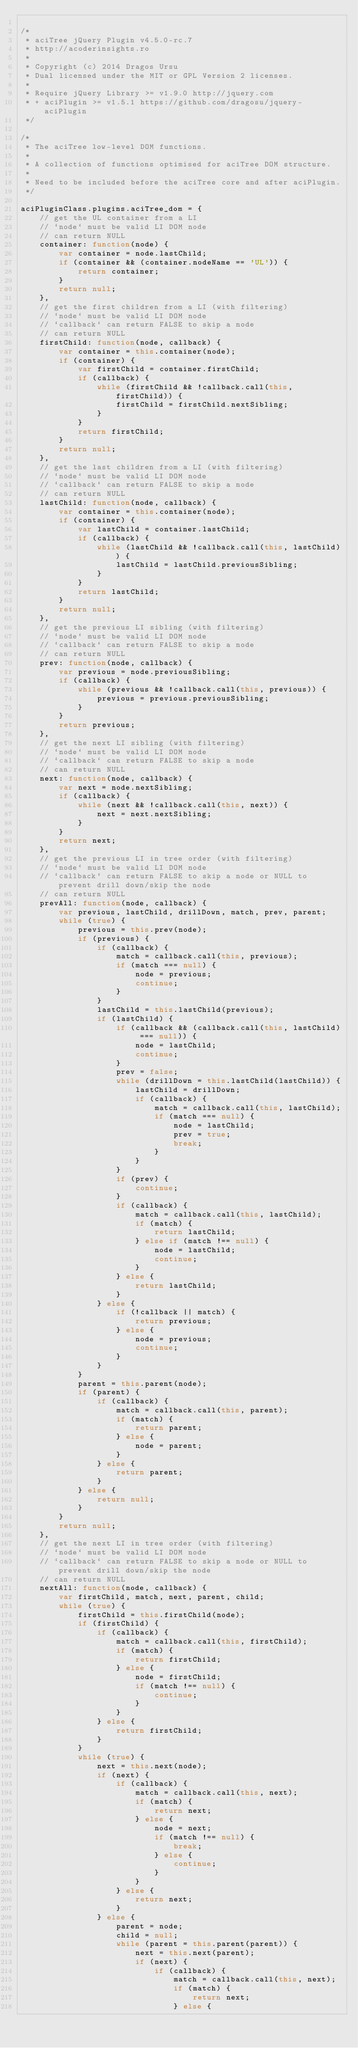<code> <loc_0><loc_0><loc_500><loc_500><_JavaScript_>
/*
 * aciTree jQuery Plugin v4.5.0-rc.7
 * http://acoderinsights.ro
 *
 * Copyright (c) 2014 Dragos Ursu
 * Dual licensed under the MIT or GPL Version 2 licenses.
 *
 * Require jQuery Library >= v1.9.0 http://jquery.com
 * + aciPlugin >= v1.5.1 https://github.com/dragosu/jquery-aciPlugin
 */

/*
 * The aciTree low-level DOM functions.
 *
 * A collection of functions optimised for aciTree DOM structure.
 *
 * Need to be included before the aciTree core and after aciPlugin.
 */

aciPluginClass.plugins.aciTree_dom = {
    // get the UL container from a LI
    // `node` must be valid LI DOM node
    // can return NULL
    container: function(node) {
        var container = node.lastChild;
        if (container && (container.nodeName == 'UL')) {
            return container;
        }
        return null;
    },
    // get the first children from a LI (with filtering)
    // `node` must be valid LI DOM node
    // `callback` can return FALSE to skip a node
    // can return NULL
    firstChild: function(node, callback) {
        var container = this.container(node);
        if (container) {
            var firstChild = container.firstChild;
            if (callback) {
                while (firstChild && !callback.call(this, firstChild)) {
                    firstChild = firstChild.nextSibling;
                }
            }
            return firstChild;
        }
        return null;
    },
    // get the last children from a LI (with filtering)
    // `node` must be valid LI DOM node
    // `callback` can return FALSE to skip a node
    // can return NULL
    lastChild: function(node, callback) {
        var container = this.container(node);
        if (container) {
            var lastChild = container.lastChild;
            if (callback) {
                while (lastChild && !callback.call(this, lastChild)) {
                    lastChild = lastChild.previousSibling;
                }
            }
            return lastChild;
        }
        return null;
    },
    // get the previous LI sibling (with filtering)
    // `node` must be valid LI DOM node
    // `callback` can return FALSE to skip a node
    // can return NULL
    prev: function(node, callback) {
        var previous = node.previousSibling;
        if (callback) {
            while (previous && !callback.call(this, previous)) {
                previous = previous.previousSibling;
            }
        }
        return previous;
    },
    // get the next LI sibling (with filtering)
    // `node` must be valid LI DOM node
    // `callback` can return FALSE to skip a node
    // can return NULL
    next: function(node, callback) {
        var next = node.nextSibling;
        if (callback) {
            while (next && !callback.call(this, next)) {
                next = next.nextSibling;
            }
        }
        return next;
    },
    // get the previous LI in tree order (with filtering)
    // `node` must be valid LI DOM node
    // `callback` can return FALSE to skip a node or NULL to prevent drill down/skip the node
    // can return NULL
    prevAll: function(node, callback) {
        var previous, lastChild, drillDown, match, prev, parent;
        while (true) {
            previous = this.prev(node);
            if (previous) {
                if (callback) {
                    match = callback.call(this, previous);
                    if (match === null) {
                        node = previous;
                        continue;
                    }
                }
                lastChild = this.lastChild(previous);
                if (lastChild) {
                    if (callback && (callback.call(this, lastChild) === null)) {
                        node = lastChild;
                        continue;
                    }
                    prev = false;
                    while (drillDown = this.lastChild(lastChild)) {
                        lastChild = drillDown;
                        if (callback) {
                            match = callback.call(this, lastChild);
                            if (match === null) {
                                node = lastChild;
                                prev = true;
                                break;
                            }
                        }
                    }
                    if (prev) {
                        continue;
                    }
                    if (callback) {
                        match = callback.call(this, lastChild);
                        if (match) {
                            return lastChild;
                        } else if (match !== null) {
                            node = lastChild;
                            continue;
                        }
                    } else {
                        return lastChild;
                    }
                } else {
                    if (!callback || match) {
                        return previous;
                    } else {
                        node = previous;
                        continue;
                    }
                }
            }
            parent = this.parent(node);
            if (parent) {
                if (callback) {
                    match = callback.call(this, parent);
                    if (match) {
                        return parent;
                    } else {
                        node = parent;
                    }
                } else {
                    return parent;
                }
            } else {
                return null;
            }
        }
        return null;
    },
    // get the next LI in tree order (with filtering)
    // `node` must be valid LI DOM node
    // `callback` can return FALSE to skip a node or NULL to prevent drill down/skip the node
    // can return NULL
    nextAll: function(node, callback) {
        var firstChild, match, next, parent, child;
        while (true) {
            firstChild = this.firstChild(node);
            if (firstChild) {
                if (callback) {
                    match = callback.call(this, firstChild);
                    if (match) {
                        return firstChild;
                    } else {
                        node = firstChild;
                        if (match !== null) {
                            continue;
                        }
                    }
                } else {
                    return firstChild;
                }
            }
            while (true) {
                next = this.next(node);
                if (next) {
                    if (callback) {
                        match = callback.call(this, next);
                        if (match) {
                            return next;
                        } else {
                            node = next;
                            if (match !== null) {
                                break;
                            } else {
                                continue;
                            }
                        }
                    } else {
                        return next;
                    }
                } else {
                    parent = node;
                    child = null;
                    while (parent = this.parent(parent)) {
                        next = this.next(parent);
                        if (next) {
                            if (callback) {
                                match = callback.call(this, next);
                                if (match) {
                                    return next;
                                } else {</code> 